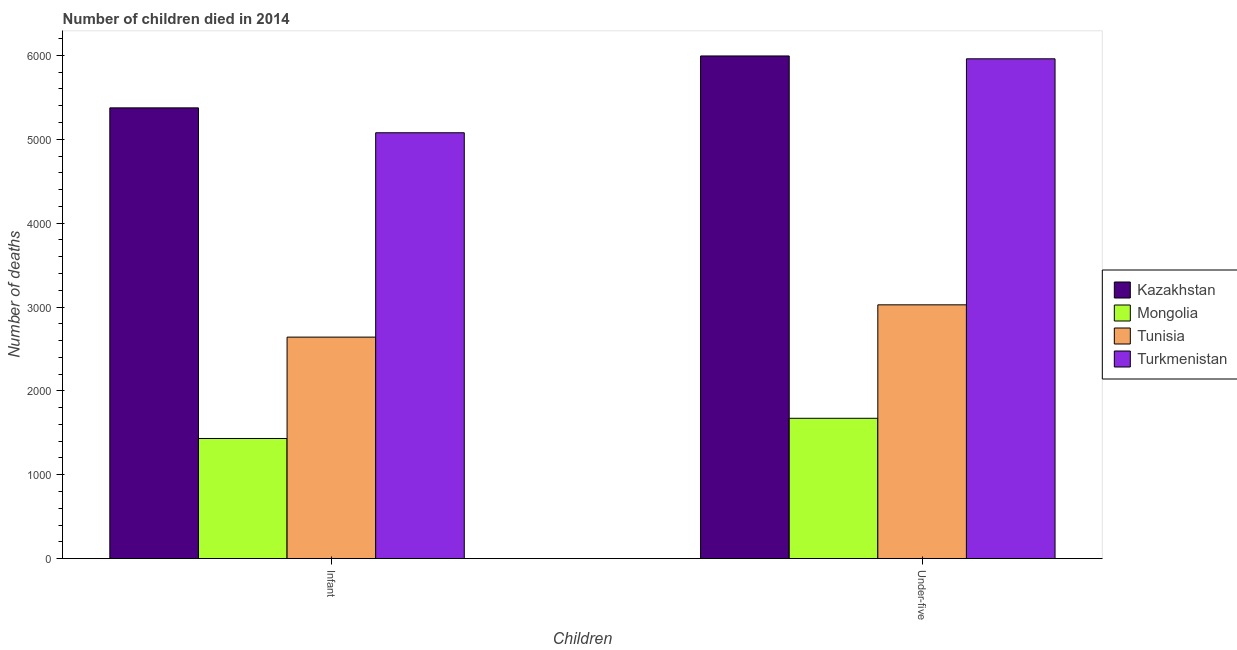Are the number of bars per tick equal to the number of legend labels?
Your response must be concise. Yes. Are the number of bars on each tick of the X-axis equal?
Give a very brief answer. Yes. How many bars are there on the 1st tick from the left?
Give a very brief answer. 4. How many bars are there on the 2nd tick from the right?
Provide a short and direct response. 4. What is the label of the 2nd group of bars from the left?
Provide a succinct answer. Under-five. What is the number of under-five deaths in Kazakhstan?
Your answer should be very brief. 5994. Across all countries, what is the maximum number of infant deaths?
Offer a terse response. 5375. Across all countries, what is the minimum number of infant deaths?
Your response must be concise. 1432. In which country was the number of infant deaths maximum?
Make the answer very short. Kazakhstan. In which country was the number of under-five deaths minimum?
Provide a succinct answer. Mongolia. What is the total number of under-five deaths in the graph?
Make the answer very short. 1.67e+04. What is the difference between the number of under-five deaths in Turkmenistan and that in Mongolia?
Your response must be concise. 4287. What is the difference between the number of under-five deaths in Tunisia and the number of infant deaths in Kazakhstan?
Provide a succinct answer. -2349. What is the average number of infant deaths per country?
Provide a succinct answer. 3631.5. What is the difference between the number of under-five deaths and number of infant deaths in Tunisia?
Provide a short and direct response. 385. What is the ratio of the number of under-five deaths in Mongolia to that in Kazakhstan?
Give a very brief answer. 0.28. Is the number of infant deaths in Turkmenistan less than that in Tunisia?
Your answer should be compact. No. What does the 3rd bar from the left in Infant represents?
Keep it short and to the point. Tunisia. What does the 2nd bar from the right in Under-five represents?
Give a very brief answer. Tunisia. How many bars are there?
Provide a short and direct response. 8. How many countries are there in the graph?
Your response must be concise. 4. Does the graph contain grids?
Provide a short and direct response. No. Where does the legend appear in the graph?
Give a very brief answer. Center right. How are the legend labels stacked?
Offer a very short reply. Vertical. What is the title of the graph?
Your answer should be compact. Number of children died in 2014. Does "Uzbekistan" appear as one of the legend labels in the graph?
Keep it short and to the point. No. What is the label or title of the X-axis?
Your answer should be compact. Children. What is the label or title of the Y-axis?
Keep it short and to the point. Number of deaths. What is the Number of deaths of Kazakhstan in Infant?
Provide a short and direct response. 5375. What is the Number of deaths of Mongolia in Infant?
Your answer should be compact. 1432. What is the Number of deaths in Tunisia in Infant?
Your answer should be compact. 2641. What is the Number of deaths in Turkmenistan in Infant?
Keep it short and to the point. 5078. What is the Number of deaths of Kazakhstan in Under-five?
Provide a short and direct response. 5994. What is the Number of deaths in Mongolia in Under-five?
Ensure brevity in your answer.  1673. What is the Number of deaths of Tunisia in Under-five?
Give a very brief answer. 3026. What is the Number of deaths in Turkmenistan in Under-five?
Provide a short and direct response. 5960. Across all Children, what is the maximum Number of deaths in Kazakhstan?
Ensure brevity in your answer.  5994. Across all Children, what is the maximum Number of deaths of Mongolia?
Your answer should be very brief. 1673. Across all Children, what is the maximum Number of deaths in Tunisia?
Make the answer very short. 3026. Across all Children, what is the maximum Number of deaths in Turkmenistan?
Provide a short and direct response. 5960. Across all Children, what is the minimum Number of deaths of Kazakhstan?
Offer a terse response. 5375. Across all Children, what is the minimum Number of deaths in Mongolia?
Give a very brief answer. 1432. Across all Children, what is the minimum Number of deaths in Tunisia?
Keep it short and to the point. 2641. Across all Children, what is the minimum Number of deaths in Turkmenistan?
Your answer should be compact. 5078. What is the total Number of deaths of Kazakhstan in the graph?
Your answer should be compact. 1.14e+04. What is the total Number of deaths of Mongolia in the graph?
Offer a very short reply. 3105. What is the total Number of deaths of Tunisia in the graph?
Your response must be concise. 5667. What is the total Number of deaths in Turkmenistan in the graph?
Ensure brevity in your answer.  1.10e+04. What is the difference between the Number of deaths of Kazakhstan in Infant and that in Under-five?
Provide a short and direct response. -619. What is the difference between the Number of deaths in Mongolia in Infant and that in Under-five?
Give a very brief answer. -241. What is the difference between the Number of deaths of Tunisia in Infant and that in Under-five?
Offer a very short reply. -385. What is the difference between the Number of deaths of Turkmenistan in Infant and that in Under-five?
Keep it short and to the point. -882. What is the difference between the Number of deaths of Kazakhstan in Infant and the Number of deaths of Mongolia in Under-five?
Your answer should be very brief. 3702. What is the difference between the Number of deaths of Kazakhstan in Infant and the Number of deaths of Tunisia in Under-five?
Offer a terse response. 2349. What is the difference between the Number of deaths of Kazakhstan in Infant and the Number of deaths of Turkmenistan in Under-five?
Make the answer very short. -585. What is the difference between the Number of deaths in Mongolia in Infant and the Number of deaths in Tunisia in Under-five?
Offer a terse response. -1594. What is the difference between the Number of deaths in Mongolia in Infant and the Number of deaths in Turkmenistan in Under-five?
Offer a terse response. -4528. What is the difference between the Number of deaths of Tunisia in Infant and the Number of deaths of Turkmenistan in Under-five?
Ensure brevity in your answer.  -3319. What is the average Number of deaths of Kazakhstan per Children?
Offer a terse response. 5684.5. What is the average Number of deaths in Mongolia per Children?
Offer a terse response. 1552.5. What is the average Number of deaths of Tunisia per Children?
Keep it short and to the point. 2833.5. What is the average Number of deaths in Turkmenistan per Children?
Offer a terse response. 5519. What is the difference between the Number of deaths in Kazakhstan and Number of deaths in Mongolia in Infant?
Your answer should be compact. 3943. What is the difference between the Number of deaths of Kazakhstan and Number of deaths of Tunisia in Infant?
Provide a short and direct response. 2734. What is the difference between the Number of deaths of Kazakhstan and Number of deaths of Turkmenistan in Infant?
Provide a succinct answer. 297. What is the difference between the Number of deaths of Mongolia and Number of deaths of Tunisia in Infant?
Your answer should be very brief. -1209. What is the difference between the Number of deaths of Mongolia and Number of deaths of Turkmenistan in Infant?
Your response must be concise. -3646. What is the difference between the Number of deaths of Tunisia and Number of deaths of Turkmenistan in Infant?
Provide a short and direct response. -2437. What is the difference between the Number of deaths of Kazakhstan and Number of deaths of Mongolia in Under-five?
Your answer should be very brief. 4321. What is the difference between the Number of deaths of Kazakhstan and Number of deaths of Tunisia in Under-five?
Offer a very short reply. 2968. What is the difference between the Number of deaths of Mongolia and Number of deaths of Tunisia in Under-five?
Provide a succinct answer. -1353. What is the difference between the Number of deaths of Mongolia and Number of deaths of Turkmenistan in Under-five?
Your answer should be compact. -4287. What is the difference between the Number of deaths in Tunisia and Number of deaths in Turkmenistan in Under-five?
Provide a short and direct response. -2934. What is the ratio of the Number of deaths in Kazakhstan in Infant to that in Under-five?
Your answer should be very brief. 0.9. What is the ratio of the Number of deaths of Mongolia in Infant to that in Under-five?
Your answer should be compact. 0.86. What is the ratio of the Number of deaths in Tunisia in Infant to that in Under-five?
Your answer should be very brief. 0.87. What is the ratio of the Number of deaths in Turkmenistan in Infant to that in Under-five?
Keep it short and to the point. 0.85. What is the difference between the highest and the second highest Number of deaths in Kazakhstan?
Your answer should be very brief. 619. What is the difference between the highest and the second highest Number of deaths of Mongolia?
Provide a succinct answer. 241. What is the difference between the highest and the second highest Number of deaths in Tunisia?
Provide a short and direct response. 385. What is the difference between the highest and the second highest Number of deaths of Turkmenistan?
Give a very brief answer. 882. What is the difference between the highest and the lowest Number of deaths of Kazakhstan?
Offer a very short reply. 619. What is the difference between the highest and the lowest Number of deaths of Mongolia?
Your response must be concise. 241. What is the difference between the highest and the lowest Number of deaths of Tunisia?
Give a very brief answer. 385. What is the difference between the highest and the lowest Number of deaths in Turkmenistan?
Your response must be concise. 882. 